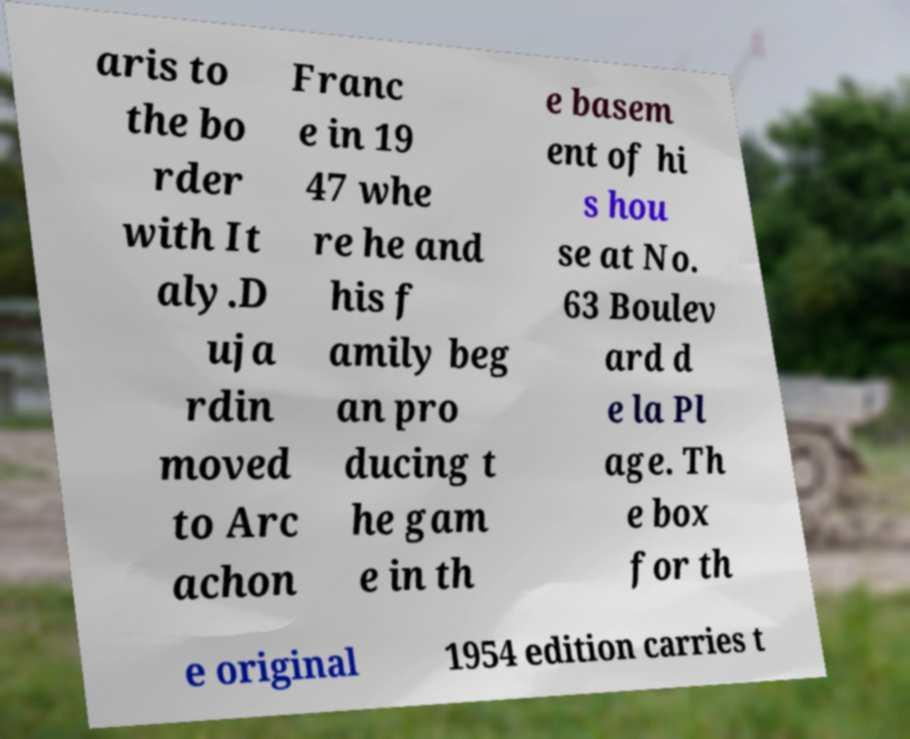Can you accurately transcribe the text from the provided image for me? aris to the bo rder with It aly.D uja rdin moved to Arc achon Franc e in 19 47 whe re he and his f amily beg an pro ducing t he gam e in th e basem ent of hi s hou se at No. 63 Boulev ard d e la Pl age. Th e box for th e original 1954 edition carries t 